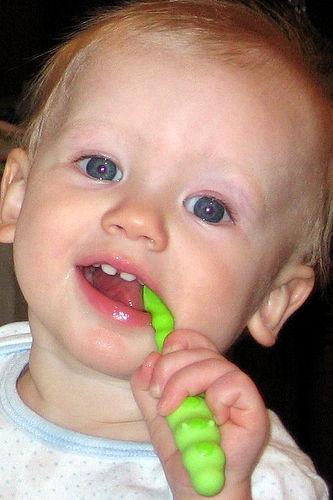What color eyes does this baby have?
Answer briefly. Blue. What is in the child's mouth?
Concise answer only. Toothbrush. What color is the item the baby is holding?
Give a very brief answer. Green. 